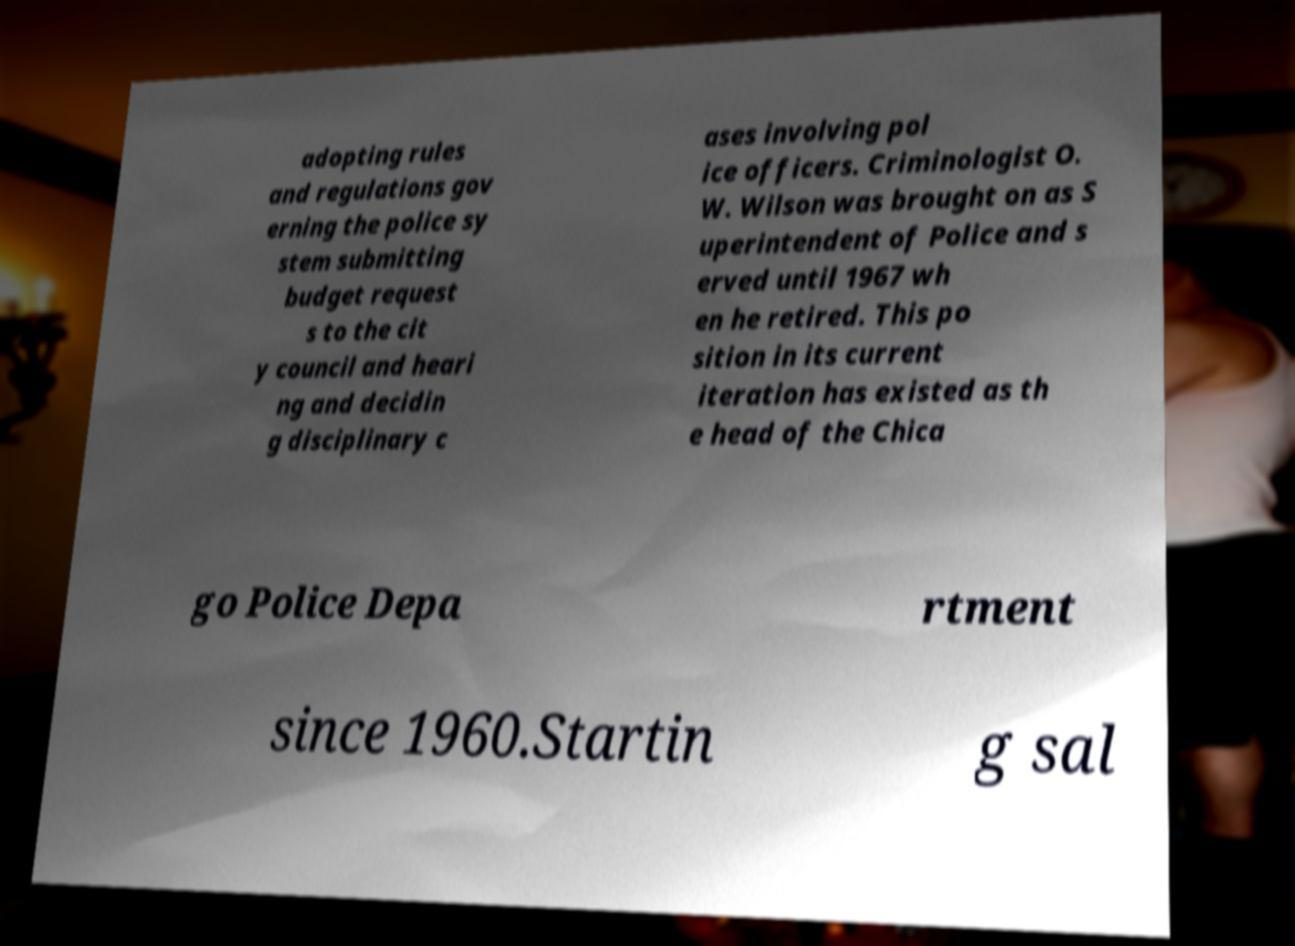Could you assist in decoding the text presented in this image and type it out clearly? adopting rules and regulations gov erning the police sy stem submitting budget request s to the cit y council and heari ng and decidin g disciplinary c ases involving pol ice officers. Criminologist O. W. Wilson was brought on as S uperintendent of Police and s erved until 1967 wh en he retired. This po sition in its current iteration has existed as th e head of the Chica go Police Depa rtment since 1960.Startin g sal 